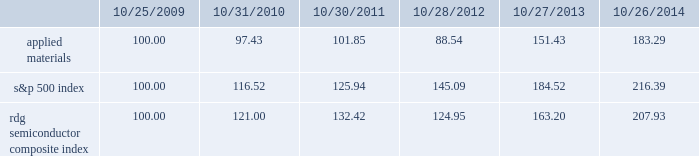Performance graph the performance graph below shows the five-year cumulative total stockholder return on applied common stock during the period from october 25 , 2009 through october 26 , 2014 .
This is compared with the cumulative total return of the standard & poor 2019s 500 stock index and the rdg semiconductor composite index over the same period .
The comparison assumes $ 100 was invested on october 25 , 2009 in applied common stock and in each of the foregoing indices and assumes reinvestment of dividends , if any .
Dollar amounts in the graph are rounded to the nearest whole dollar .
The performance shown in the graph represents past performance and should not be considered an indication of future performance .
Comparison of 5 year cumulative total return* among applied materials , inc. , the s&p 500 index 201cs&p 201d is a registered trademark of standard & poor 2019s financial services llc , a subsidiary of the mcgraw-hill companies , inc. .
Dividends during fiscal 2014 , applied 2019s board of directors declared four quarterly cash dividends of $ 0.10 per share each .
During fiscal 2013 , applied 2019s board of directors declared three quarterly cash dividends of $ 0.10 per share each and one quarterly cash dividend of $ 0.09 per share .
During fiscal 2012 , applied 2019s board of directors declared three quarterly cash dividends of $ 0.09 per share each and one quarterly cash dividend of $ 0.08 .
Dividends declared during fiscal 2014 , 2013 and 2012 totaled $ 487 million , $ 469 million and $ 438 million , respectively .
Applied currently anticipates that it will continue to pay cash dividends on a quarterly basis in the future , although the declaration and amount of any future cash dividends are at the discretion of the board of directors and will depend on applied 2019s financial condition , results of operations , capital requirements , business conditions and other factors , as well as a determination that cash dividends are in the best interests of applied 2019s stockholders .
$ 100 invested on 10/25/09 in stock or 10/31/09 in index , including reinvestment of dividends .
Indexes calculated on month-end basis .
And the rdg semiconductor composite index 183145 97 102 121 132 10/25/09 10/31/10 10/30/11 10/28/12 10/27/13 10/26/14 applied materials , inc .
S&p 500 rdg semiconductor composite .
How much more return was given for investing in the overall market rather than applied materials from 2009 to 2014 ? ( in a percentage )? 
Rationale: to figure out the percentage return , we need to find out how much each one grew over the years first . one can do this by subtracting by 100 and making that number a percentage because we started at 100 . then we subtract the two percentages to find out how much more return one stock gave us .
Computations: ((216.39 - 100) - (183.29 - 100))
Answer: 33.1. Performance graph the performance graph below shows the five-year cumulative total stockholder return on applied common stock during the period from october 25 , 2009 through october 26 , 2014 .
This is compared with the cumulative total return of the standard & poor 2019s 500 stock index and the rdg semiconductor composite index over the same period .
The comparison assumes $ 100 was invested on october 25 , 2009 in applied common stock and in each of the foregoing indices and assumes reinvestment of dividends , if any .
Dollar amounts in the graph are rounded to the nearest whole dollar .
The performance shown in the graph represents past performance and should not be considered an indication of future performance .
Comparison of 5 year cumulative total return* among applied materials , inc. , the s&p 500 index 201cs&p 201d is a registered trademark of standard & poor 2019s financial services llc , a subsidiary of the mcgraw-hill companies , inc. .
Dividends during fiscal 2014 , applied 2019s board of directors declared four quarterly cash dividends of $ 0.10 per share each .
During fiscal 2013 , applied 2019s board of directors declared three quarterly cash dividends of $ 0.10 per share each and one quarterly cash dividend of $ 0.09 per share .
During fiscal 2012 , applied 2019s board of directors declared three quarterly cash dividends of $ 0.09 per share each and one quarterly cash dividend of $ 0.08 .
Dividends declared during fiscal 2014 , 2013 and 2012 totaled $ 487 million , $ 469 million and $ 438 million , respectively .
Applied currently anticipates that it will continue to pay cash dividends on a quarterly basis in the future , although the declaration and amount of any future cash dividends are at the discretion of the board of directors and will depend on applied 2019s financial condition , results of operations , capital requirements , business conditions and other factors , as well as a determination that cash dividends are in the best interests of applied 2019s stockholders .
$ 100 invested on 10/25/09 in stock or 10/31/09 in index , including reinvestment of dividends .
Indexes calculated on month-end basis .
And the rdg semiconductor composite index 183145 97 102 121 132 10/25/09 10/31/10 10/30/11 10/28/12 10/27/13 10/26/14 applied materials , inc .
S&p 500 rdg semiconductor composite .
How many shares received dividends during 2014 , ( in millions ) ? 
Computations: (487 / (0.10 * 4))
Answer: 1217.5. 